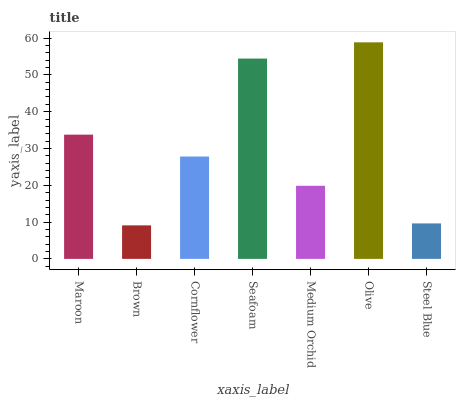Is Brown the minimum?
Answer yes or no. Yes. Is Olive the maximum?
Answer yes or no. Yes. Is Cornflower the minimum?
Answer yes or no. No. Is Cornflower the maximum?
Answer yes or no. No. Is Cornflower greater than Brown?
Answer yes or no. Yes. Is Brown less than Cornflower?
Answer yes or no. Yes. Is Brown greater than Cornflower?
Answer yes or no. No. Is Cornflower less than Brown?
Answer yes or no. No. Is Cornflower the high median?
Answer yes or no. Yes. Is Cornflower the low median?
Answer yes or no. Yes. Is Brown the high median?
Answer yes or no. No. Is Olive the low median?
Answer yes or no. No. 